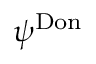Convert formula to latex. <formula><loc_0><loc_0><loc_500><loc_500>\psi ^ { D o n }</formula> 